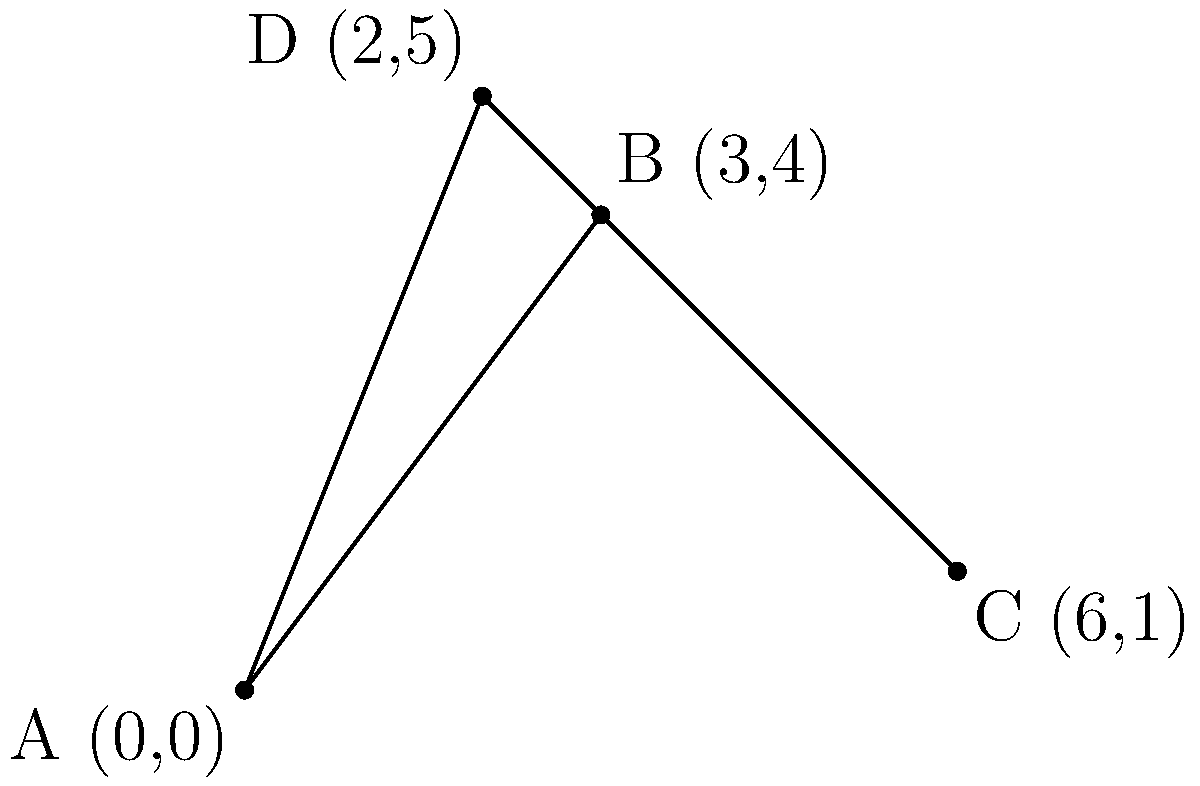You've marked four fishing spots on a map. The spots are connected by straight lines to form a shape. If each unit on the map represents 1 kilometer, and you catch about 50 fish per square kilometer, how many fish do you think you might catch in the area inside the shape? Let's break this down into simple steps:

1. First, we need to find the area of the shape. The shape is a quadrilateral (4-sided figure).

2. To find the area of an irregular quadrilateral, we can split it into two triangles and add their areas.

3. Let's split it into triangles ABC and ACD.

4. For triangle ABC:
   Base = 6 units, Height = 4 units
   Area of ABC = $\frac{1}{2} \times 6 \times 4 = 12$ square units

5. For triangle ACD:
   Base = 2 units, Height = 5 units
   Area of ACD = $\frac{1}{2} \times 2 \times 5 = 5$ square units

6. Total area = Area of ABC + Area of ACD
               = 12 + 5 = 17 square units

7. Each unit represents 1 kilometer, so the area is 17 square kilometers.

8. You catch about 50 fish per square kilometer.

9. So, estimated catch = 17 × 50 = 850 fish

Therefore, you might catch about 850 fish in this area.
Answer: 850 fish 